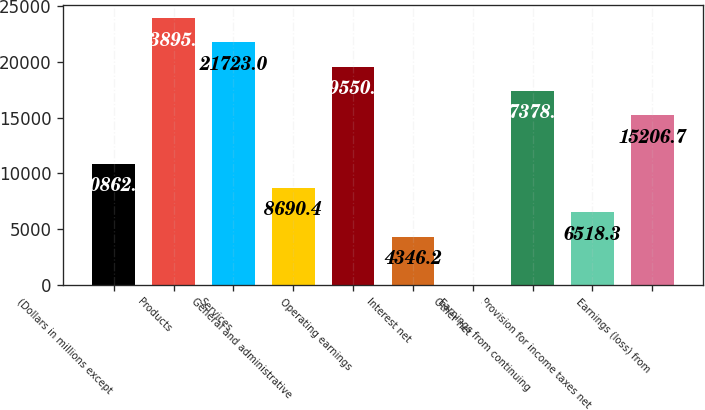Convert chart to OTSL. <chart><loc_0><loc_0><loc_500><loc_500><bar_chart><fcel>(Dollars in millions except<fcel>Products<fcel>Services<fcel>General and administrative<fcel>Operating earnings<fcel>Interest net<fcel>Other net<fcel>Earnings from continuing<fcel>Provision for income taxes net<fcel>Earnings (loss) from<nl><fcel>10862.5<fcel>23895.1<fcel>21723<fcel>8690.4<fcel>19550.9<fcel>4346.2<fcel>2<fcel>17378.8<fcel>6518.3<fcel>15206.7<nl></chart> 